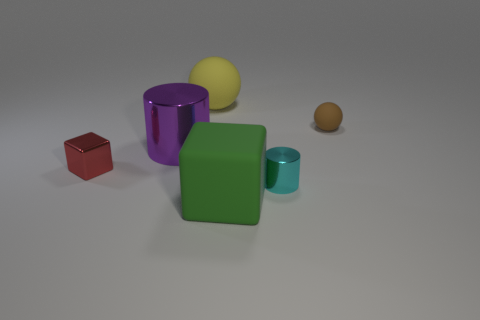Are there any balls made of the same material as the big green cube?
Your answer should be very brief. Yes. There is a cube in front of the metal cylinder that is in front of the shiny cube; what is it made of?
Provide a short and direct response. Rubber. Are there an equal number of tiny matte things that are in front of the small matte sphere and purple shiny cylinders that are behind the tiny cyan cylinder?
Keep it short and to the point. No. Does the purple object have the same shape as the tiny red metallic thing?
Your answer should be compact. No. The object that is in front of the shiny cube and on the left side of the tiny cyan shiny cylinder is made of what material?
Your response must be concise. Rubber. How many other rubber things are the same shape as the red thing?
Keep it short and to the point. 1. There is a shiny thing that is on the left side of the large purple cylinder that is behind the cylinder that is in front of the small red block; what size is it?
Offer a terse response. Small. Are there more small brown objects in front of the big purple thing than tiny green metal things?
Offer a very short reply. No. Are any purple things visible?
Provide a short and direct response. Yes. What number of purple cylinders have the same size as the red metallic block?
Make the answer very short. 0. 